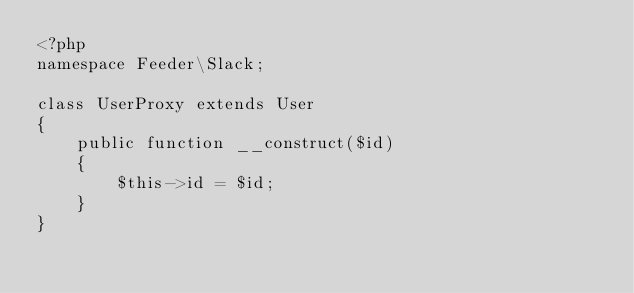<code> <loc_0><loc_0><loc_500><loc_500><_PHP_><?php
namespace Feeder\Slack;

class UserProxy extends User
{
    public function __construct($id)
    {
        $this->id = $id;
    }
}
</code> 